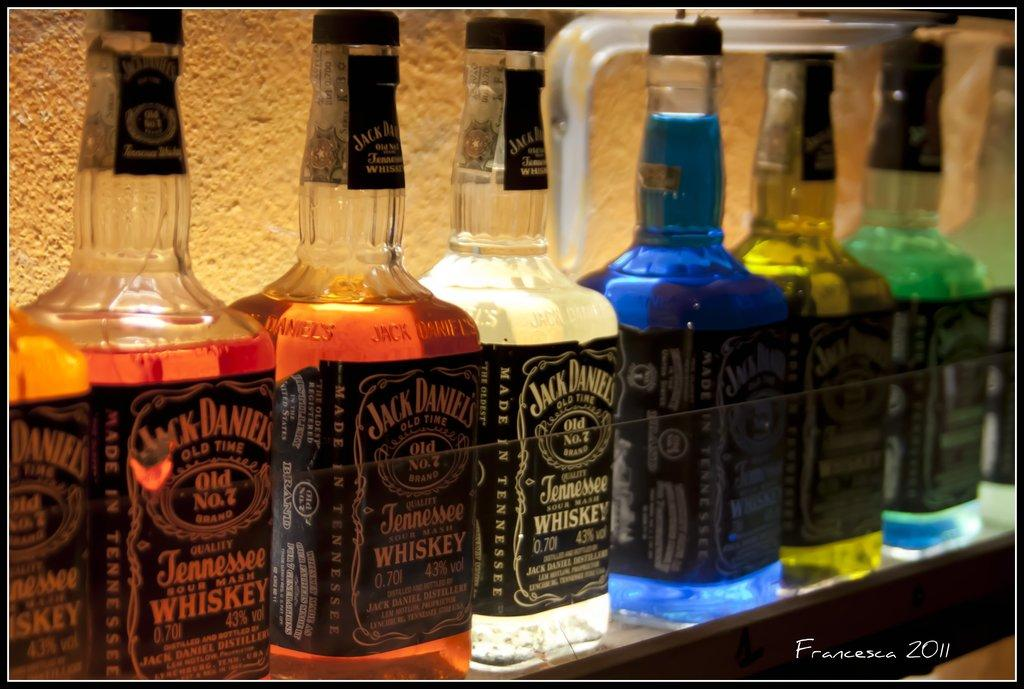<image>
Render a clear and concise summary of the photo. A row of Jack Daniels Old No.7 liquor bottles are filled with various colored liquids. 